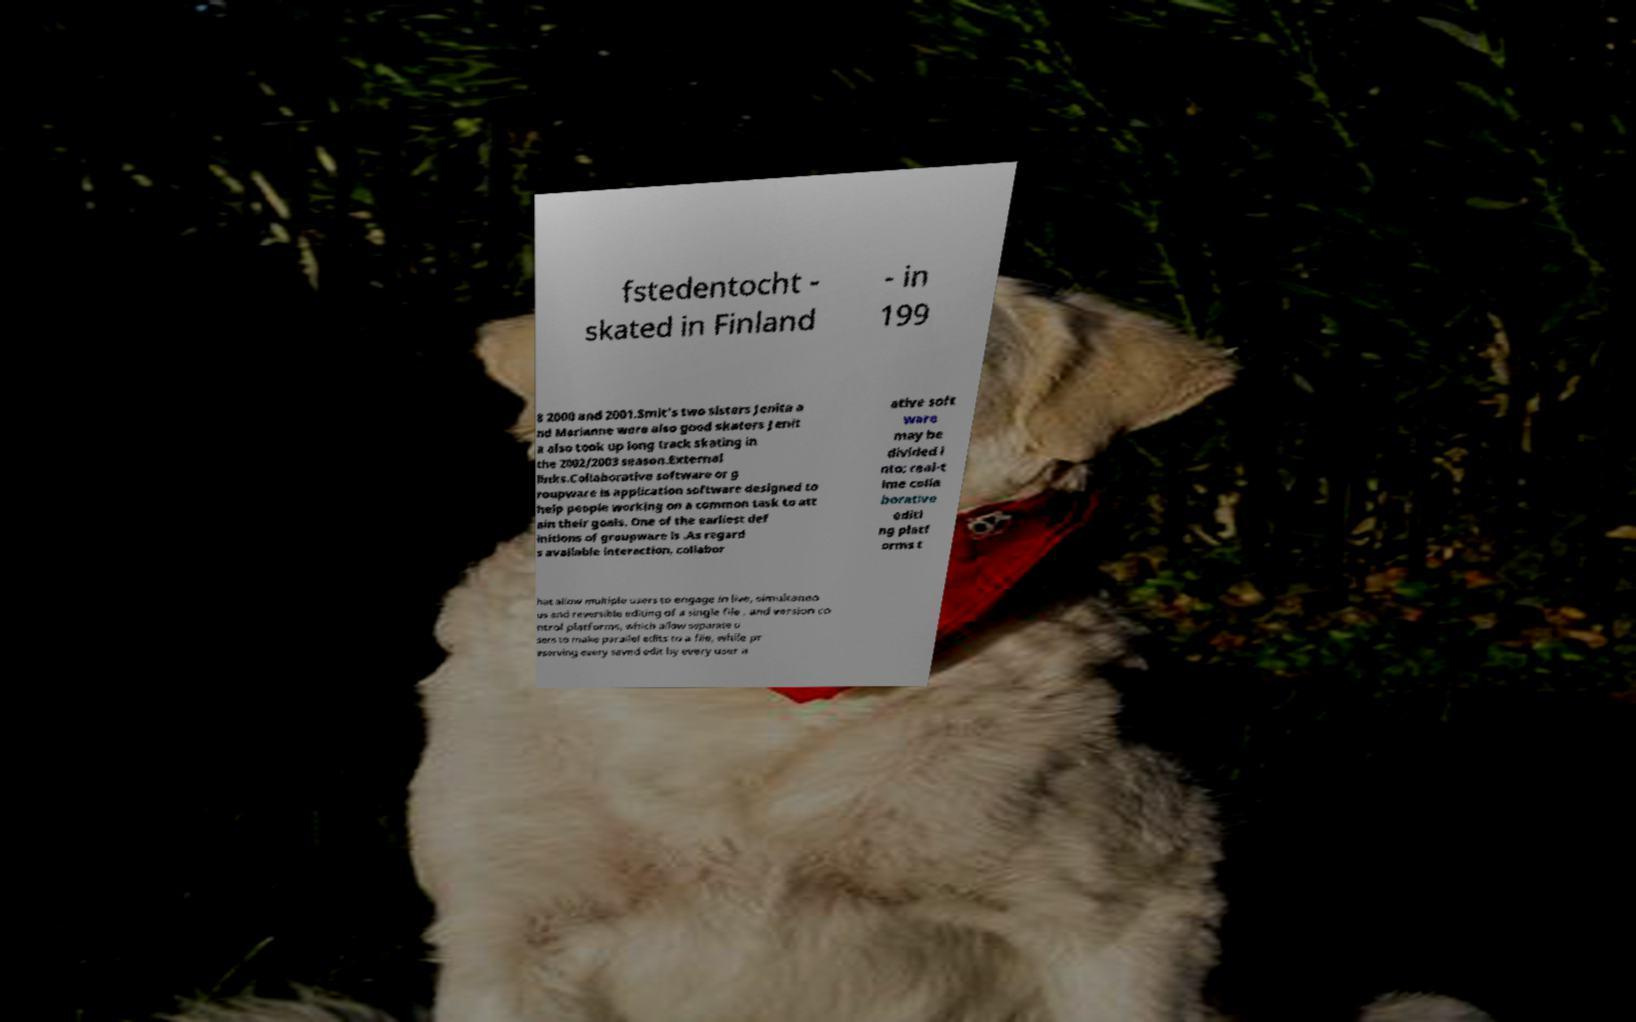There's text embedded in this image that I need extracted. Can you transcribe it verbatim? fstedentocht - skated in Finland - in 199 8 2000 and 2001.Smit's two sisters Jenita a nd Marianne were also good skaters Jenit a also took up long track skating in the 2002/2003 season.External links.Collaborative software or g roupware is application software designed to help people working on a common task to att ain their goals. One of the earliest def initions of groupware is .As regard s available interaction, collabor ative soft ware may be divided i nto: real-t ime colla borative editi ng platf orms t hat allow multiple users to engage in live, simultaneo us and reversible editing of a single file , and version co ntrol platforms, which allow separate u sers to make parallel edits to a file, while pr eserving every saved edit by every user a 